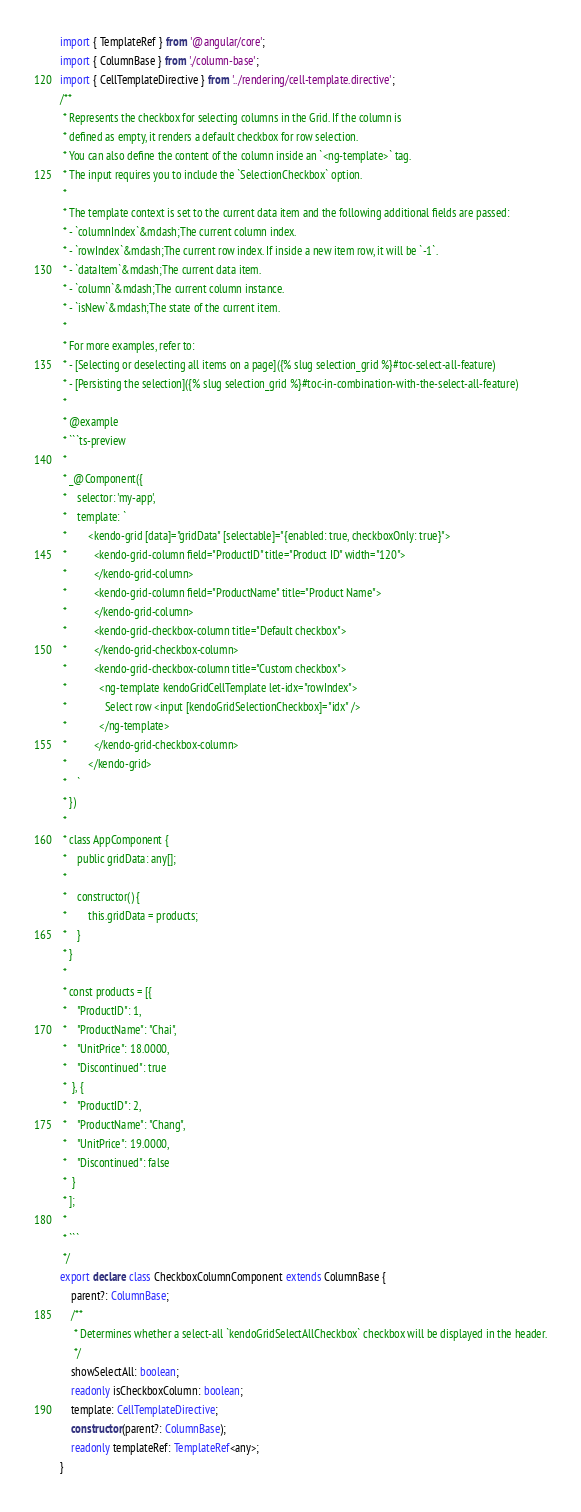<code> <loc_0><loc_0><loc_500><loc_500><_TypeScript_>import { TemplateRef } from '@angular/core';
import { ColumnBase } from './column-base';
import { CellTemplateDirective } from '../rendering/cell-template.directive';
/**
 * Represents the checkbox for selecting columns in the Grid. If the column is
 * defined as empty, it renders a default checkbox for row selection.
 * You can also define the content of the column inside an `<ng-template>` tag.
 * The input requires you to include the `SelectionCheckbox` option.
 *
 * The template context is set to the current data item and the following additional fields are passed:
 * - `columnIndex`&mdash;The current column index.
 * - `rowIndex`&mdash;The current row index. If inside a new item row, it will be `-1`.
 * - `dataItem`&mdash;The current data item.
 * - `column`&mdash;The current column instance.
 * - `isNew`&mdash;The state of the current item.
 *
 * For more examples, refer to:
 * - [Selecting or deselecting all items on a page]({% slug selection_grid %}#toc-select-all-feature)
 * - [Persisting the selection]({% slug selection_grid %}#toc-in-combination-with-the-select-all-feature)
 *
 * @example
 * ```ts-preview
 *
 * _@Component({
 *    selector: 'my-app',
 *    template: `
 *        <kendo-grid [data]="gridData" [selectable]="{enabled: true, checkboxOnly: true}">
 *          <kendo-grid-column field="ProductID" title="Product ID" width="120">
 *          </kendo-grid-column>
 *          <kendo-grid-column field="ProductName" title="Product Name">
 *          </kendo-grid-column>
 *          <kendo-grid-checkbox-column title="Default checkbox">
 *          </kendo-grid-checkbox-column>
 *          <kendo-grid-checkbox-column title="Custom checkbox">
 *            <ng-template kendoGridCellTemplate let-idx="rowIndex">
 *              Select row <input [kendoGridSelectionCheckbox]="idx" />
 *            </ng-template>
 *          </kendo-grid-checkbox-column>
 *        </kendo-grid>
 *    `
 * })
 *
 * class AppComponent {
 *    public gridData: any[];
 *
 *    constructor() {
 *        this.gridData = products;
 *    }
 * }
 *
 * const products = [{
 *    "ProductID": 1,
 *    "ProductName": "Chai",
 *    "UnitPrice": 18.0000,
 *    "Discontinued": true
 *  }, {
 *    "ProductID": 2,
 *    "ProductName": "Chang",
 *    "UnitPrice": 19.0000,
 *    "Discontinued": false
 *  }
 * ];
 *
 * ```
 */
export declare class CheckboxColumnComponent extends ColumnBase {
    parent?: ColumnBase;
    /**
     * Determines whether a select-all `kendoGridSelectAllCheckbox` checkbox will be displayed in the header.
     */
    showSelectAll: boolean;
    readonly isCheckboxColumn: boolean;
    template: CellTemplateDirective;
    constructor(parent?: ColumnBase);
    readonly templateRef: TemplateRef<any>;
}
</code> 